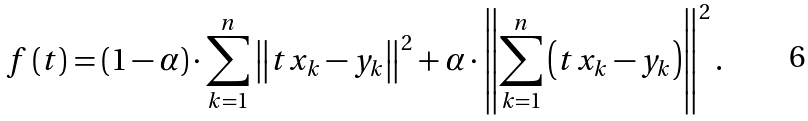Convert formula to latex. <formula><loc_0><loc_0><loc_500><loc_500>f \left ( t \right ) = \left ( 1 - \alpha \right ) \cdot \sum _ { k = 1 } ^ { n } \left \| t x _ { k } - y _ { k } \right \| ^ { 2 } + \alpha \cdot \left \| \sum _ { k = 1 } ^ { n } \left ( t x _ { k } - y _ { k } \right ) \right \| ^ { 2 } .</formula> 